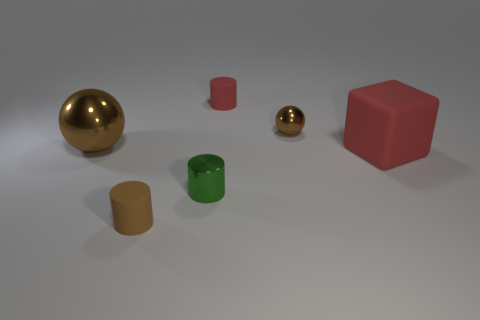Is there any other thing of the same color as the big metal sphere?
Your response must be concise. Yes. What number of rubber things are either brown things or tiny spheres?
Make the answer very short. 1. There is a large object that is left of the brown thing in front of the sphere that is left of the brown rubber thing; what is its material?
Your answer should be very brief. Metal. What is the small object right of the rubber cylinder to the right of the tiny metal cylinder made of?
Provide a succinct answer. Metal. Is the size of the sphere left of the small green metallic object the same as the red object that is behind the red matte cube?
Your answer should be compact. No. What number of tiny things are red matte cylinders or brown metallic things?
Your response must be concise. 2. What number of things are either tiny matte objects in front of the tiny sphere or large cylinders?
Provide a succinct answer. 1. Is the tiny ball the same color as the large metallic sphere?
Your answer should be compact. Yes. What number of other things are the same shape as the brown rubber object?
Give a very brief answer. 2. What number of purple things are large matte cubes or rubber cylinders?
Give a very brief answer. 0. 